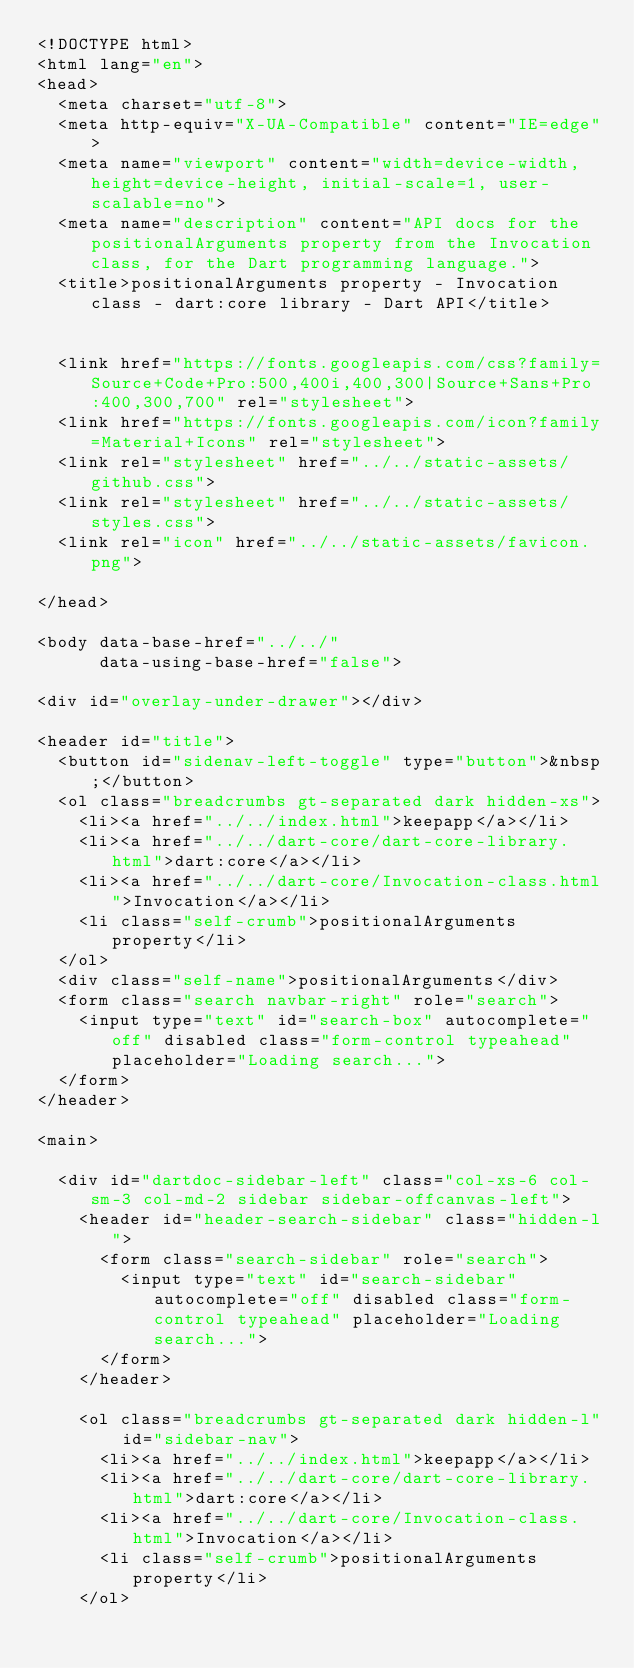<code> <loc_0><loc_0><loc_500><loc_500><_HTML_><!DOCTYPE html>
<html lang="en">
<head>
  <meta charset="utf-8">
  <meta http-equiv="X-UA-Compatible" content="IE=edge">
  <meta name="viewport" content="width=device-width, height=device-height, initial-scale=1, user-scalable=no">
  <meta name="description" content="API docs for the positionalArguments property from the Invocation class, for the Dart programming language.">
  <title>positionalArguments property - Invocation class - dart:core library - Dart API</title>

  
  <link href="https://fonts.googleapis.com/css?family=Source+Code+Pro:500,400i,400,300|Source+Sans+Pro:400,300,700" rel="stylesheet">
  <link href="https://fonts.googleapis.com/icon?family=Material+Icons" rel="stylesheet">
  <link rel="stylesheet" href="../../static-assets/github.css">
  <link rel="stylesheet" href="../../static-assets/styles.css">
  <link rel="icon" href="../../static-assets/favicon.png">

</head>

<body data-base-href="../../"
      data-using-base-href="false">

<div id="overlay-under-drawer"></div>

<header id="title">
  <button id="sidenav-left-toggle" type="button">&nbsp;</button>
  <ol class="breadcrumbs gt-separated dark hidden-xs">
    <li><a href="../../index.html">keepapp</a></li>
    <li><a href="../../dart-core/dart-core-library.html">dart:core</a></li>
    <li><a href="../../dart-core/Invocation-class.html">Invocation</a></li>
    <li class="self-crumb">positionalArguments property</li>
  </ol>
  <div class="self-name">positionalArguments</div>
  <form class="search navbar-right" role="search">
    <input type="text" id="search-box" autocomplete="off" disabled class="form-control typeahead" placeholder="Loading search...">
  </form>
</header>

<main>

  <div id="dartdoc-sidebar-left" class="col-xs-6 col-sm-3 col-md-2 sidebar sidebar-offcanvas-left">
    <header id="header-search-sidebar" class="hidden-l">
      <form class="search-sidebar" role="search">
        <input type="text" id="search-sidebar" autocomplete="off" disabled class="form-control typeahead" placeholder="Loading search...">
      </form>
    </header>
    
    <ol class="breadcrumbs gt-separated dark hidden-l" id="sidebar-nav">
      <li><a href="../../index.html">keepapp</a></li>
      <li><a href="../../dart-core/dart-core-library.html">dart:core</a></li>
      <li><a href="../../dart-core/Invocation-class.html">Invocation</a></li>
      <li class="self-crumb">positionalArguments property</li>
    </ol>
    </code> 